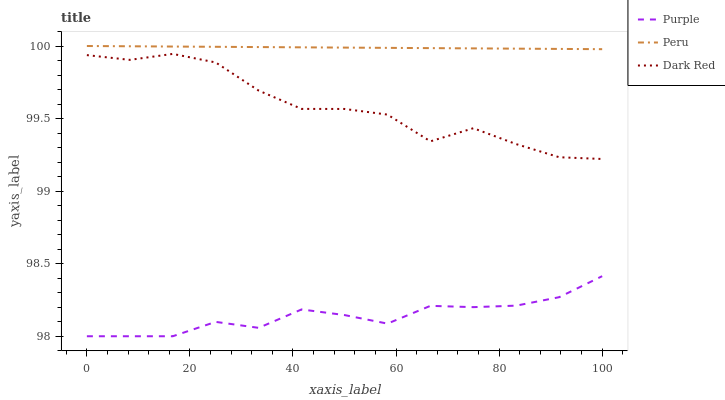Does Purple have the minimum area under the curve?
Answer yes or no. Yes. Does Peru have the maximum area under the curve?
Answer yes or no. Yes. Does Dark Red have the minimum area under the curve?
Answer yes or no. No. Does Dark Red have the maximum area under the curve?
Answer yes or no. No. Is Peru the smoothest?
Answer yes or no. Yes. Is Dark Red the roughest?
Answer yes or no. Yes. Is Dark Red the smoothest?
Answer yes or no. No. Is Peru the roughest?
Answer yes or no. No. Does Purple have the lowest value?
Answer yes or no. Yes. Does Dark Red have the lowest value?
Answer yes or no. No. Does Peru have the highest value?
Answer yes or no. Yes. Does Dark Red have the highest value?
Answer yes or no. No. Is Dark Red less than Peru?
Answer yes or no. Yes. Is Dark Red greater than Purple?
Answer yes or no. Yes. Does Dark Red intersect Peru?
Answer yes or no. No. 